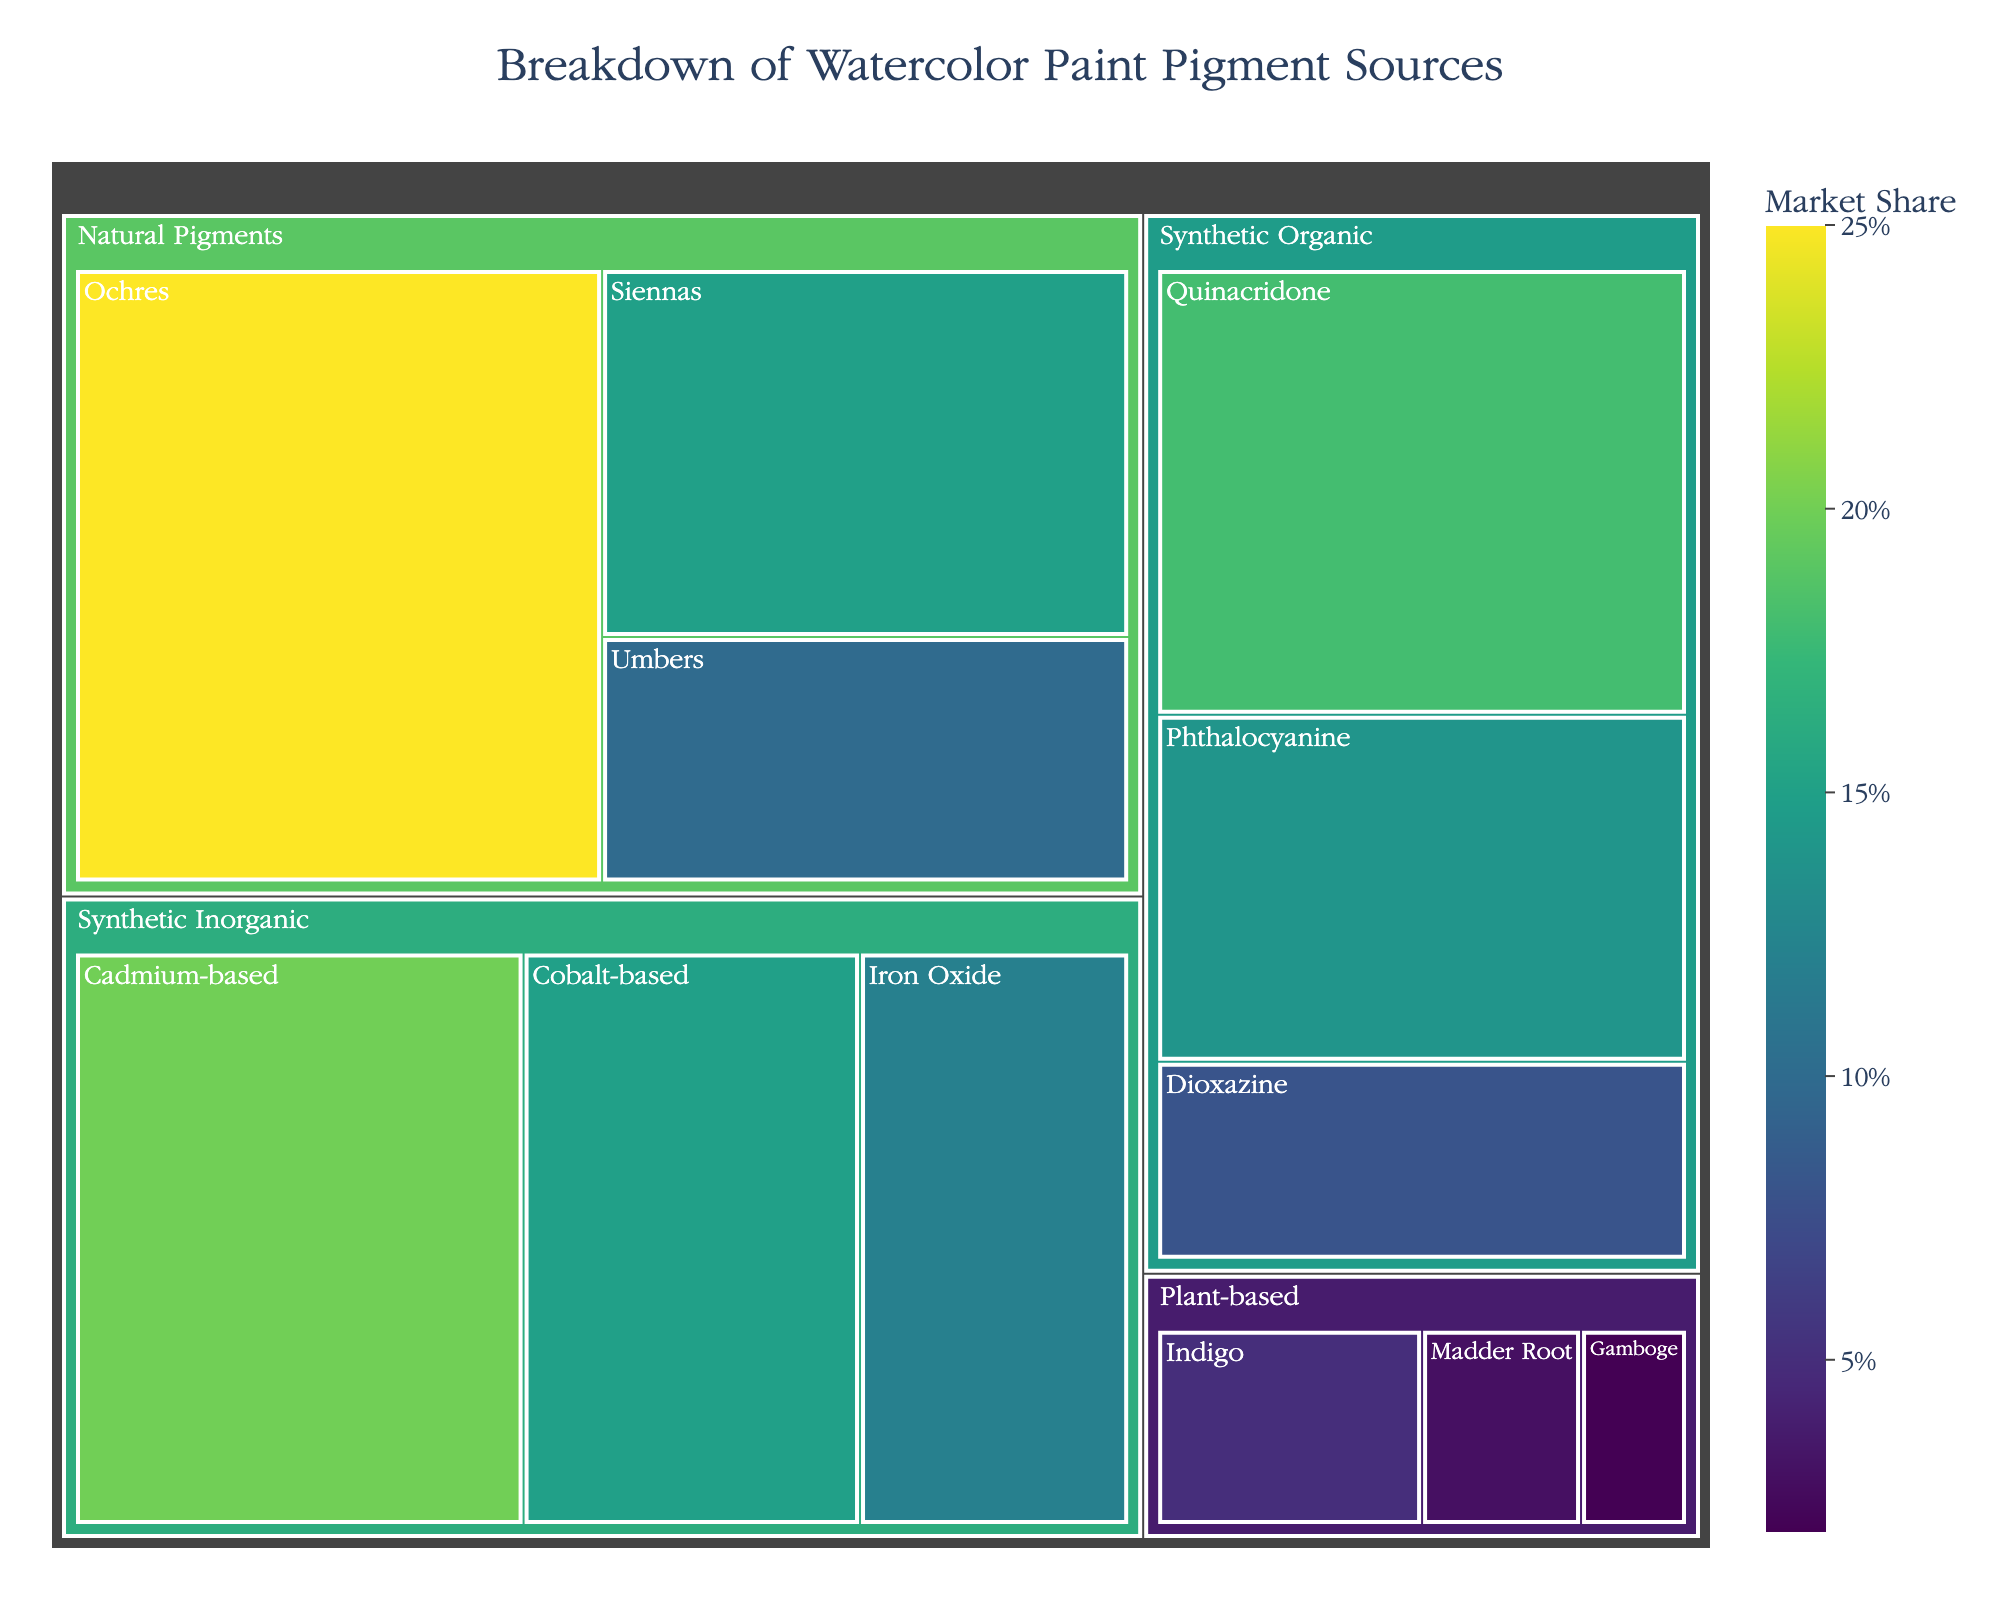What's the title of the treemap? The title can be found at the top of the figure, usually larger in font size and centrally aligned.
Answer: Breakdown of Watercolor Paint Pigment Sources Which subcategory of pigments has the largest market share? By examining the relative size of the sections in the treemap and the values associated with them, we can identify the largest.
Answer: Ochres Compare the market share of Plant-based pigments to Synthetic Organic pigments. Which is greater? The total market share of Plant-based is the sum of its subcategories (5 + 3 + 2 = 10) and for Synthetic Organic is (18 + 14 + 8 = 40). Clearly, Synthetic Organic is greater.
Answer: Synthetic Organic What is the combined market share of Quinacridone and Cadmium-based pigments? Sum the values of Quinacridone (18) and Cadmium-based (20) pigments.
Answer: 38 Identify the smallest subcategory in the treemap. Look for the smallest section or label representing the lowest value in the figure.
Answer: Gamboge Which category has the highest combined market share? Sum the values of each subcategory within each category and compare: 
 - Natural Pigments: 25 + 15 + 10 = 50
 - Synthetic Inorganic: 20 + 15 + 12 = 47
 - Synthetic Organic: 18 + 14 + 8 = 40
 - Plant-based: 5 + 3 + 2 = 10
Natural Pigments has the highest total.
Answer: Natural Pigments How does the market share of Cadmium-based pigments compare to Cobalt-based pigments? Compare their values directly: Cadmium-based (20) vs Cobalt-based (15).
Answer: Cadmium-based is greater What percentage of the total market share do all Synthetic Inorganic pigments occupy? First, calculate the total market share (50 + 47 + 40 + 10 = 147). Then, find the percentage for Synthetic Inorganic (47 / 147) * 100 ≈ 32%.
Answer: Approximately 32% If you combine the value of all Natural Pigments, how much larger is it compared to Plant-based pigments? Calculate the difference between the combined Natural Pigments (50) and Plant-based (10) values.
Answer: 40 Are Umbers or Iron Oxide pigments more popular based on market share? Compare their values directly: Umbers (10) vs Iron Oxide (12).
Answer: Iron Oxide 